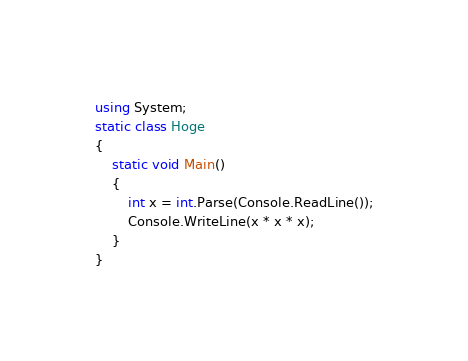Convert code to text. <code><loc_0><loc_0><loc_500><loc_500><_C#_>using System;
static class Hoge
{
    static void Main()
    {
        int x = int.Parse(Console.ReadLine());
        Console.WriteLine(x * x * x);
    }
}
</code> 